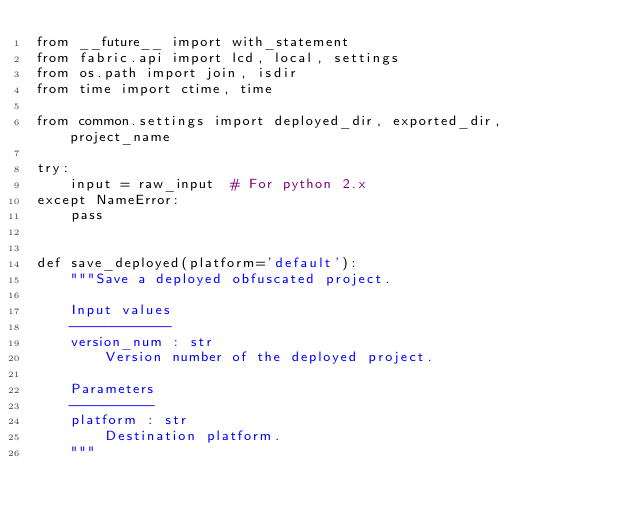Convert code to text. <code><loc_0><loc_0><loc_500><loc_500><_Python_>from __future__ import with_statement
from fabric.api import lcd, local, settings
from os.path import join, isdir
from time import ctime, time

from common.settings import deployed_dir, exported_dir, project_name

try:
    input = raw_input  # For python 2.x
except NameError:
    pass


def save_deployed(platform='default'):
    """Save a deployed obfuscated project.

    Input values
    ------------
    version_num : str
        Version number of the deployed project.

    Parameters
    ----------
    platform : str
        Destination platform.
    """</code> 